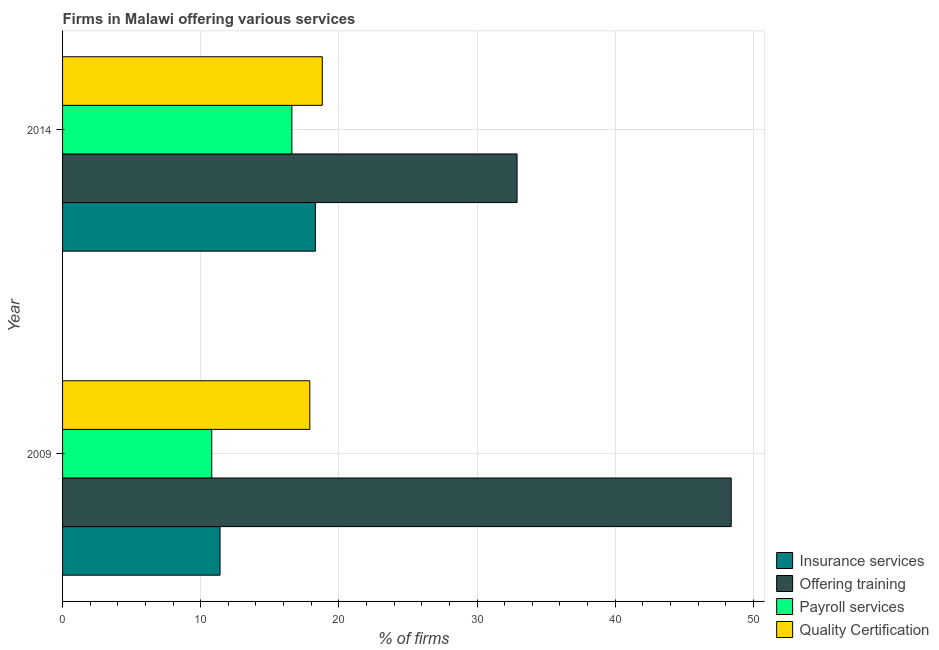Are the number of bars on each tick of the Y-axis equal?
Keep it short and to the point. Yes. How many bars are there on the 2nd tick from the top?
Your response must be concise. 4. How many bars are there on the 1st tick from the bottom?
Provide a short and direct response. 4. What is the label of the 2nd group of bars from the top?
Provide a short and direct response. 2009. In how many cases, is the number of bars for a given year not equal to the number of legend labels?
Keep it short and to the point. 0. What is the percentage of firms offering training in 2009?
Ensure brevity in your answer.  48.4. Across all years, what is the maximum percentage of firms offering training?
Provide a succinct answer. 48.4. Across all years, what is the minimum percentage of firms offering payroll services?
Give a very brief answer. 10.8. In which year was the percentage of firms offering payroll services maximum?
Offer a terse response. 2014. What is the total percentage of firms offering quality certification in the graph?
Offer a very short reply. 36.7. What is the difference between the percentage of firms offering payroll services in 2009 and that in 2014?
Offer a terse response. -5.8. What is the difference between the percentage of firms offering quality certification in 2009 and the percentage of firms offering payroll services in 2014?
Your response must be concise. 1.3. What is the average percentage of firms offering quality certification per year?
Your answer should be very brief. 18.35. In the year 2009, what is the difference between the percentage of firms offering payroll services and percentage of firms offering insurance services?
Provide a short and direct response. -0.6. In how many years, is the percentage of firms offering insurance services greater than 34 %?
Your response must be concise. 0. What is the ratio of the percentage of firms offering quality certification in 2009 to that in 2014?
Your response must be concise. 0.95. Is the percentage of firms offering payroll services in 2009 less than that in 2014?
Make the answer very short. Yes. Is the difference between the percentage of firms offering insurance services in 2009 and 2014 greater than the difference between the percentage of firms offering quality certification in 2009 and 2014?
Offer a terse response. No. Is it the case that in every year, the sum of the percentage of firms offering payroll services and percentage of firms offering quality certification is greater than the sum of percentage of firms offering training and percentage of firms offering insurance services?
Keep it short and to the point. No. What does the 1st bar from the top in 2014 represents?
Keep it short and to the point. Quality Certification. What does the 3rd bar from the bottom in 2014 represents?
Give a very brief answer. Payroll services. Are all the bars in the graph horizontal?
Your response must be concise. Yes. Are the values on the major ticks of X-axis written in scientific E-notation?
Make the answer very short. No. Does the graph contain any zero values?
Ensure brevity in your answer.  No. Where does the legend appear in the graph?
Your answer should be very brief. Bottom right. How are the legend labels stacked?
Your answer should be very brief. Vertical. What is the title of the graph?
Your answer should be very brief. Firms in Malawi offering various services . Does "UNHCR" appear as one of the legend labels in the graph?
Provide a succinct answer. No. What is the label or title of the X-axis?
Make the answer very short. % of firms. What is the label or title of the Y-axis?
Ensure brevity in your answer.  Year. What is the % of firms in Insurance services in 2009?
Make the answer very short. 11.4. What is the % of firms of Offering training in 2009?
Keep it short and to the point. 48.4. What is the % of firms in Insurance services in 2014?
Your response must be concise. 18.3. What is the % of firms of Offering training in 2014?
Provide a short and direct response. 32.9. Across all years, what is the maximum % of firms in Offering training?
Give a very brief answer. 48.4. Across all years, what is the maximum % of firms in Quality Certification?
Make the answer very short. 18.8. Across all years, what is the minimum % of firms of Offering training?
Provide a short and direct response. 32.9. Across all years, what is the minimum % of firms in Quality Certification?
Offer a very short reply. 17.9. What is the total % of firms in Insurance services in the graph?
Ensure brevity in your answer.  29.7. What is the total % of firms of Offering training in the graph?
Offer a very short reply. 81.3. What is the total % of firms of Payroll services in the graph?
Your response must be concise. 27.4. What is the total % of firms of Quality Certification in the graph?
Give a very brief answer. 36.7. What is the difference between the % of firms in Insurance services in 2009 and that in 2014?
Offer a very short reply. -6.9. What is the difference between the % of firms of Offering training in 2009 and that in 2014?
Make the answer very short. 15.5. What is the difference between the % of firms in Insurance services in 2009 and the % of firms in Offering training in 2014?
Your answer should be compact. -21.5. What is the difference between the % of firms of Insurance services in 2009 and the % of firms of Payroll services in 2014?
Provide a short and direct response. -5.2. What is the difference between the % of firms in Offering training in 2009 and the % of firms in Payroll services in 2014?
Your answer should be very brief. 31.8. What is the difference between the % of firms in Offering training in 2009 and the % of firms in Quality Certification in 2014?
Give a very brief answer. 29.6. What is the average % of firms of Insurance services per year?
Make the answer very short. 14.85. What is the average % of firms of Offering training per year?
Give a very brief answer. 40.65. What is the average % of firms of Payroll services per year?
Ensure brevity in your answer.  13.7. What is the average % of firms in Quality Certification per year?
Your answer should be compact. 18.35. In the year 2009, what is the difference between the % of firms in Insurance services and % of firms in Offering training?
Your answer should be very brief. -37. In the year 2009, what is the difference between the % of firms in Offering training and % of firms in Payroll services?
Your response must be concise. 37.6. In the year 2009, what is the difference between the % of firms in Offering training and % of firms in Quality Certification?
Offer a terse response. 30.5. In the year 2014, what is the difference between the % of firms of Insurance services and % of firms of Offering training?
Offer a terse response. -14.6. In the year 2014, what is the difference between the % of firms in Insurance services and % of firms in Quality Certification?
Keep it short and to the point. -0.5. In the year 2014, what is the difference between the % of firms of Offering training and % of firms of Quality Certification?
Offer a terse response. 14.1. What is the ratio of the % of firms in Insurance services in 2009 to that in 2014?
Provide a short and direct response. 0.62. What is the ratio of the % of firms of Offering training in 2009 to that in 2014?
Keep it short and to the point. 1.47. What is the ratio of the % of firms of Payroll services in 2009 to that in 2014?
Offer a very short reply. 0.65. What is the ratio of the % of firms in Quality Certification in 2009 to that in 2014?
Provide a succinct answer. 0.95. What is the difference between the highest and the second highest % of firms of Insurance services?
Your answer should be compact. 6.9. What is the difference between the highest and the second highest % of firms in Offering training?
Your response must be concise. 15.5. What is the difference between the highest and the second highest % of firms of Payroll services?
Your response must be concise. 5.8. What is the difference between the highest and the second highest % of firms in Quality Certification?
Ensure brevity in your answer.  0.9. What is the difference between the highest and the lowest % of firms of Insurance services?
Ensure brevity in your answer.  6.9. What is the difference between the highest and the lowest % of firms of Offering training?
Offer a terse response. 15.5. What is the difference between the highest and the lowest % of firms in Payroll services?
Give a very brief answer. 5.8. 